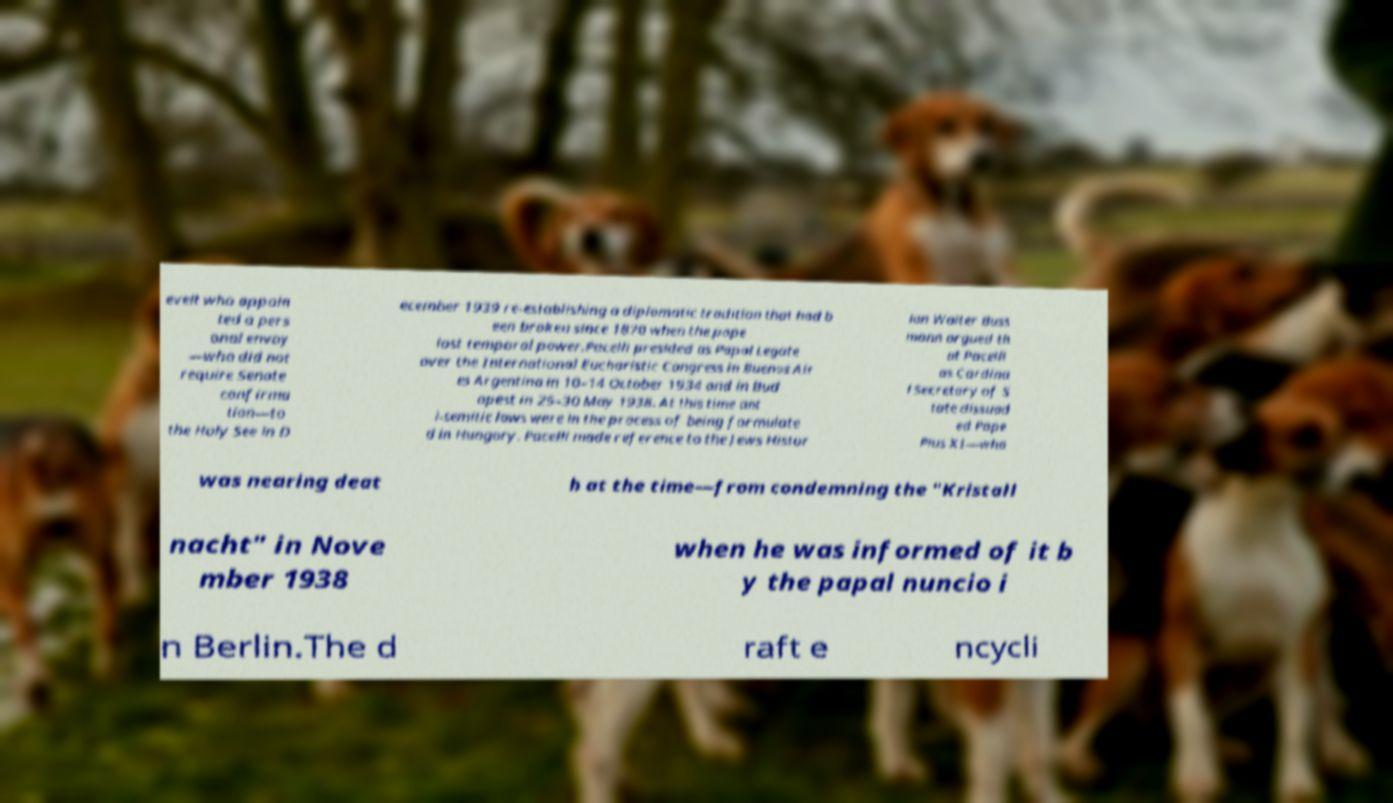There's text embedded in this image that I need extracted. Can you transcribe it verbatim? evelt who appoin ted a pers onal envoy —who did not require Senate confirma tion—to the Holy See in D ecember 1939 re-establishing a diplomatic tradition that had b een broken since 1870 when the pope lost temporal power.Pacelli presided as Papal Legate over the International Eucharistic Congress in Buenos Air es Argentina in 10–14 October 1934 and in Bud apest in 25–30 May 1938. At this time ant i-semitic laws were in the process of being formulate d in Hungary. Pacelli made reference to the Jews Histor ian Walter Buss mann argued th at Pacelli as Cardina l Secretary of S tate dissuad ed Pope Pius XI—who was nearing deat h at the time—from condemning the "Kristall nacht" in Nove mber 1938 when he was informed of it b y the papal nuncio i n Berlin.The d raft e ncycli 